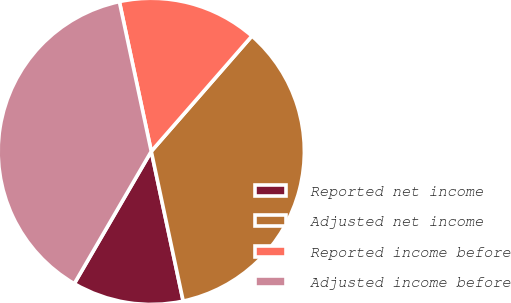Convert chart. <chart><loc_0><loc_0><loc_500><loc_500><pie_chart><fcel>Reported net income<fcel>Adjusted net income<fcel>Reported income before<fcel>Adjusted income before<nl><fcel>11.73%<fcel>35.24%<fcel>14.76%<fcel>38.27%<nl></chart> 